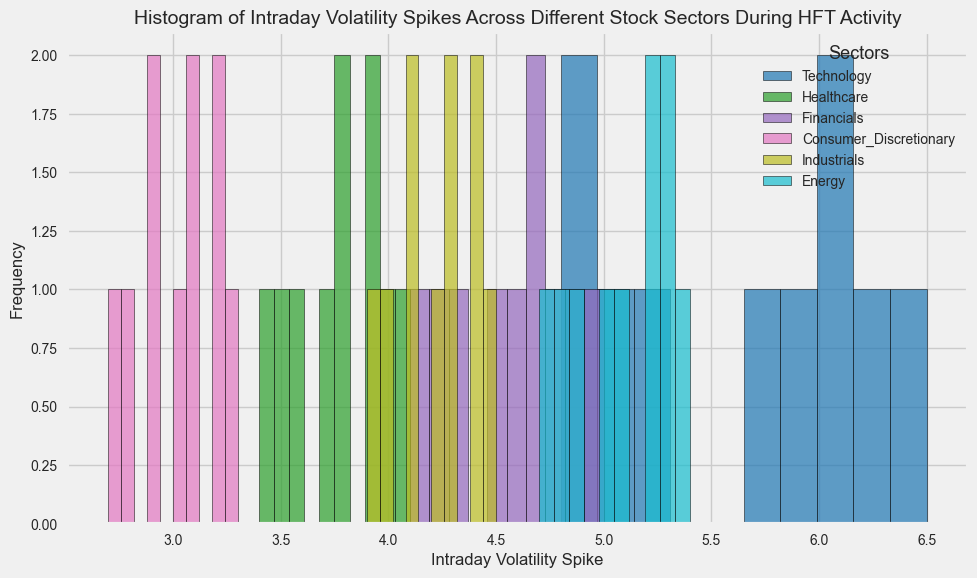How many stock sectors are represented in the histogram? Look at the legend to see the different sectors listed. These represent the unique sectors present in the data.
Answer: 5 Which sector has the highest individual intraday volatility spike? Compare the highest values of the bins for each sector's histogram. The Technology sector appears to have the highest individual spike.
Answer: Technology What is the average intraday volatility spike in the Consumer Discretionary sector? Add the values for the Consumer Discretionary sector: 2.9, 3.2, 2.8, 3.1, 3.0, 3.3, 2.7, 3.1, 2.9, 3.2, and divide by the number of data points (10). The sum is 30.2, so the average is 30.2 / 10 = 3.02.
Answer: 3.02 Which sector has the most concentrated spikes within a single bin range? Observe the histograms to see which sector's bars are tallest and most clustered within one bin range. The Financials sector has the most spikes concentrated within the 4.5-4.9 bin range.
Answer: Financials Is there a sector where the intraday volatility spikes distribution is approximately uniform across the bins? Look for histograms where the frequencies (heights of bars) are more or less equal across different bins. The Technology sector shows a relatively even distribution across bins compared to others.
Answer: Technology Between the Energy and Industrials sectors, which one has on average higher intraday volatility spikes? Calculate the average for Energy and Industrials. For Energy: (5.0 + 5.2 + 4.7 + 5.3 + 5.1 + 5.4 + 4.8 + 5.2 + 4.9 + 5.3) / 10 = 5.09. For Industrials: (4.0 + 4.3 + 4.1 + 4.4 + 4.2 + 4.5 + 3.9 + 4.3 + 4.1 + 4.4) / 10 = 4.22. Hence, Energy has a higher average spike.
Answer: Energy Which sector shows the least variability in intraday volatility spikes? Look for the histogram with bars concentrated closely together around a central value, implying less variability. The Healthcare sector has the least variability with values mostly around 3.4 to 4.1.
Answer: Healthcare What is the most frequent intraday volatility spike range for the Technology sector? Identify the bin with the highest frequency (tallest bar) within the Technology sector's histogram. The most frequent spike range for Technology is 6.0 to 6.5.
Answer: 6.0-6.5 